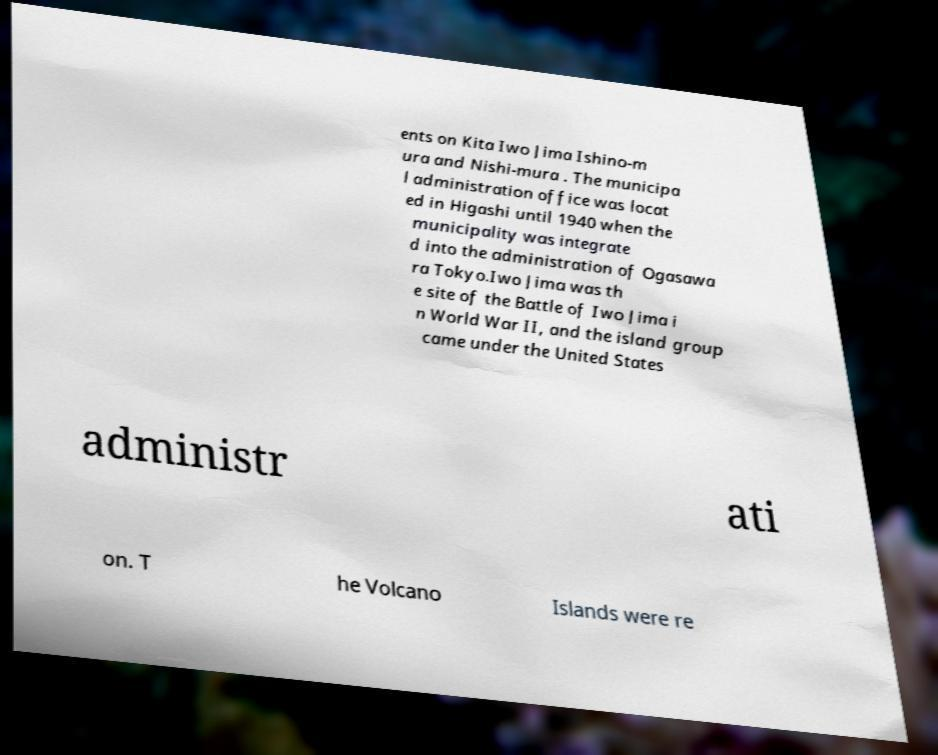What messages or text are displayed in this image? I need them in a readable, typed format. ents on Kita Iwo Jima Ishino-m ura and Nishi-mura . The municipa l administration office was locat ed in Higashi until 1940 when the municipality was integrate d into the administration of Ogasawa ra Tokyo.Iwo Jima was th e site of the Battle of Iwo Jima i n World War II, and the island group came under the United States administr ati on. T he Volcano Islands were re 